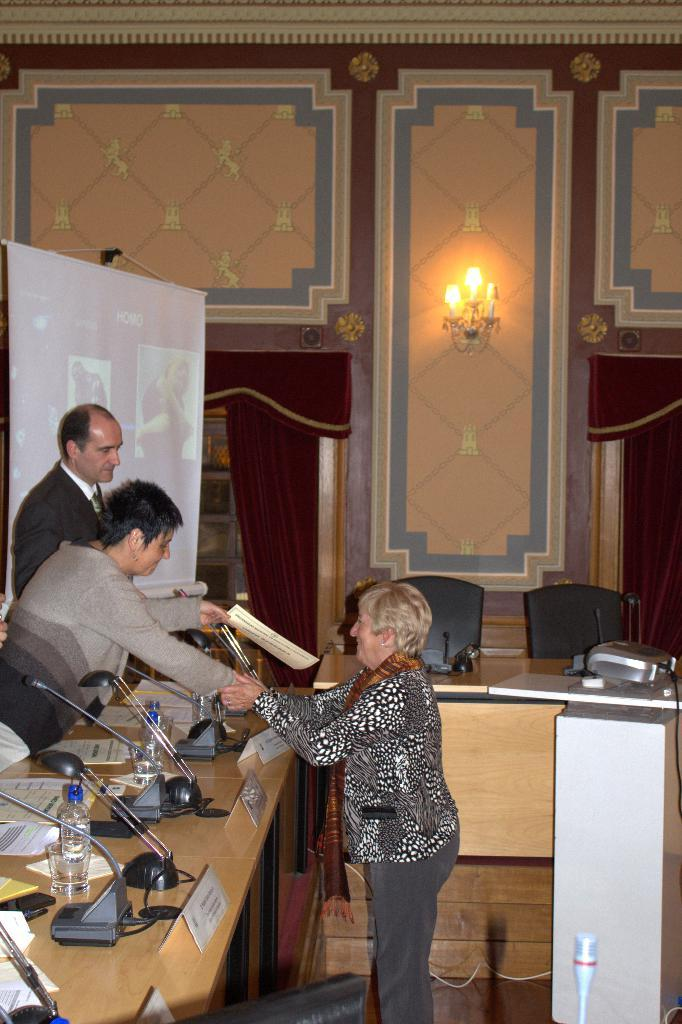How many women are present in the image? There are two women in the image. What is the woman on the right doing? The woman on the right is shaking her hands in front of the other woman. Is there anyone else present in the image besides the two women? Yes, there is another person standing beside the woman on the right. What can be seen in the background of the image? There is a projected image in the background. What type of sweater is the tree wearing in the image? There is no tree or sweater present in the image. How is the knot tied on the woman's hair in the image? There is no mention of a knot or the woman's hair in the provided facts, so we cannot answer this question. 